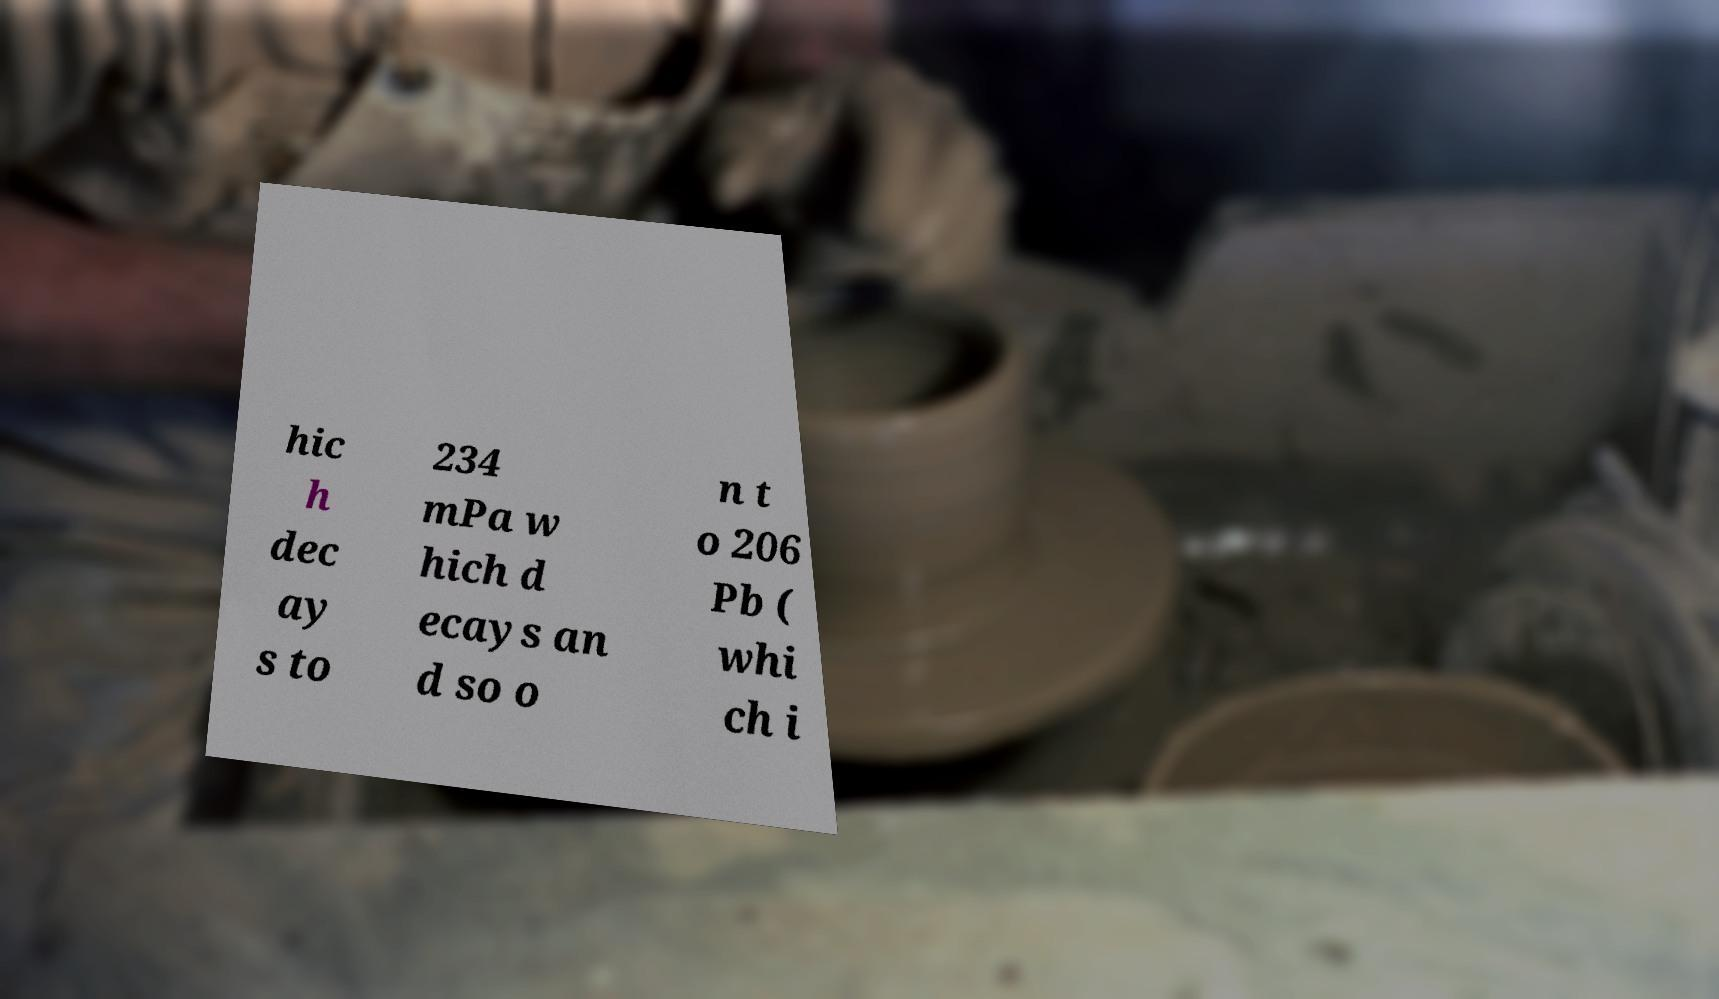Please identify and transcribe the text found in this image. hic h dec ay s to 234 mPa w hich d ecays an d so o n t o 206 Pb ( whi ch i 